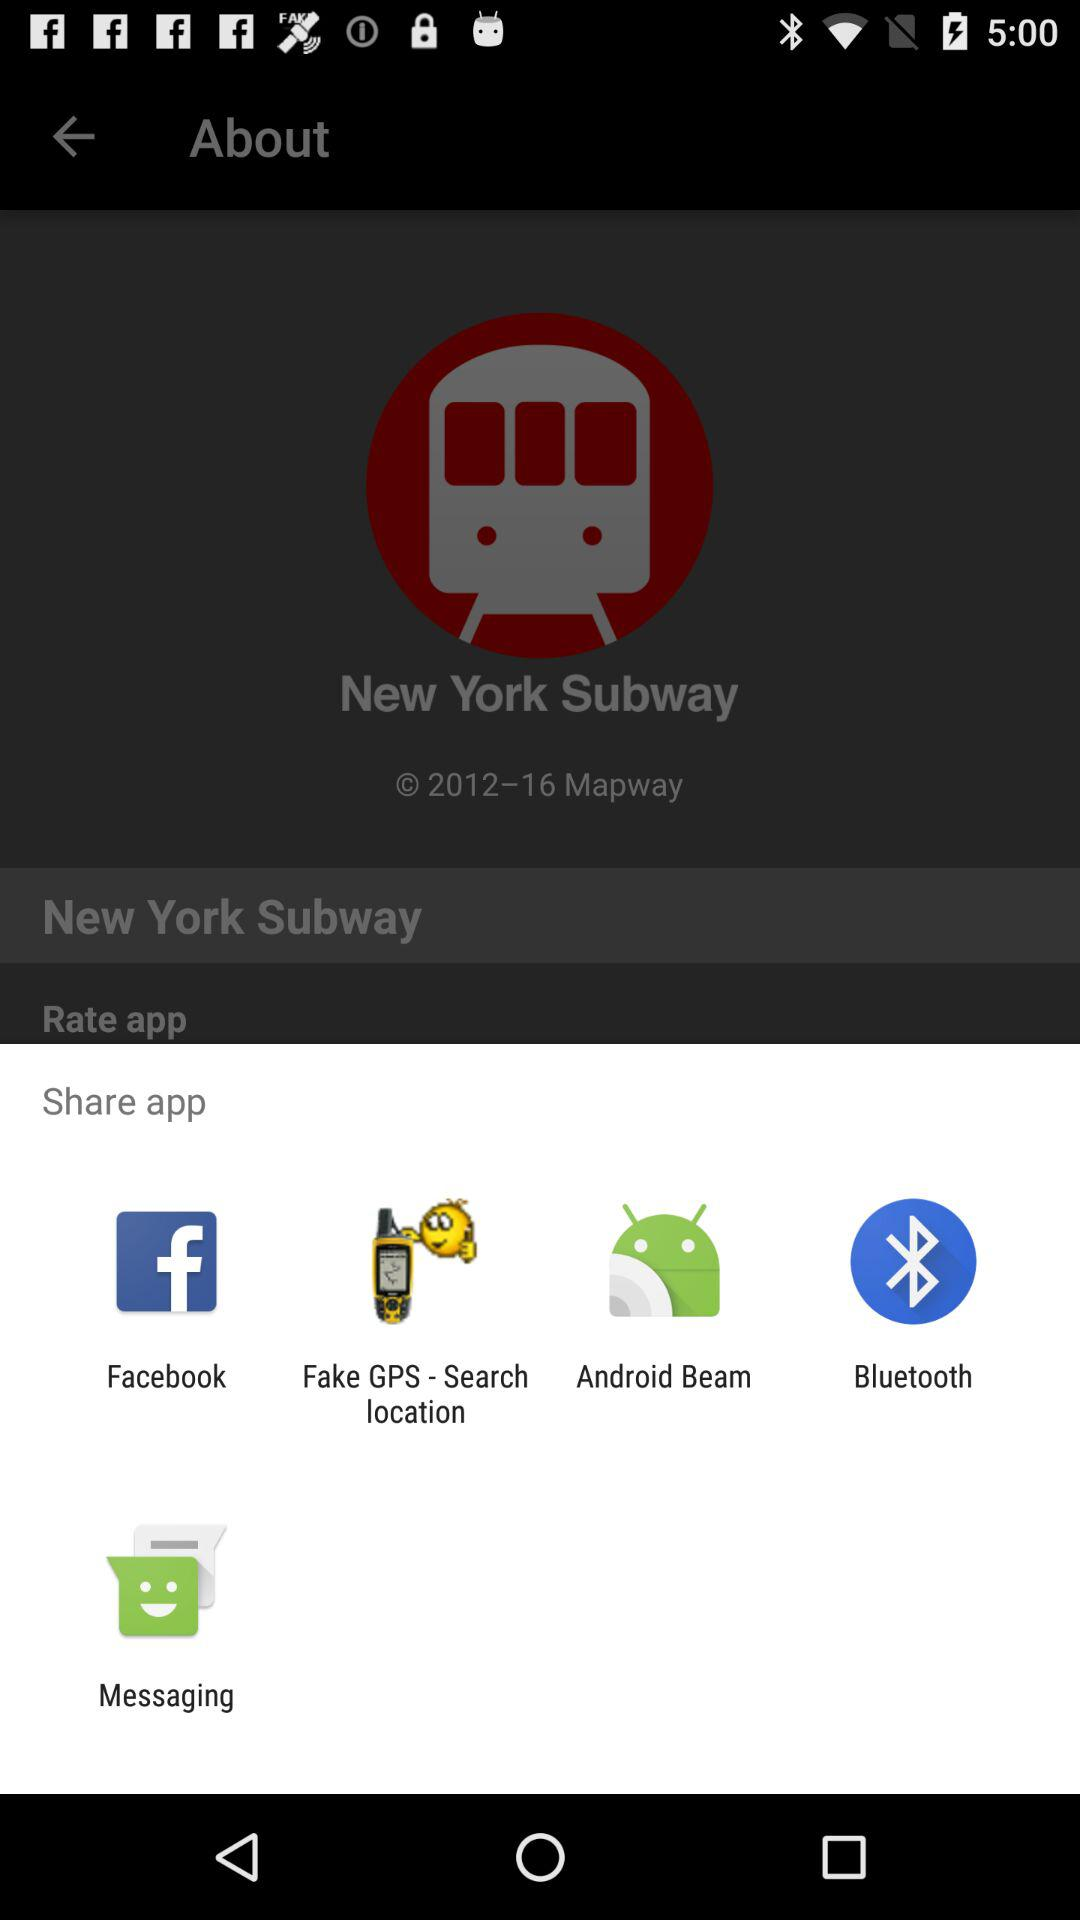Through which app can we share? You can share through "Facebook", "Fake GPS - Search location", "Android Beam", "Bluetooth" and "Messaging". 